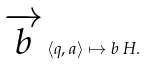Convert formula to latex. <formula><loc_0><loc_0><loc_500><loc_500>\overrightarrow { b } \, \langle q , a \rangle \mapsto b \, H .</formula> 